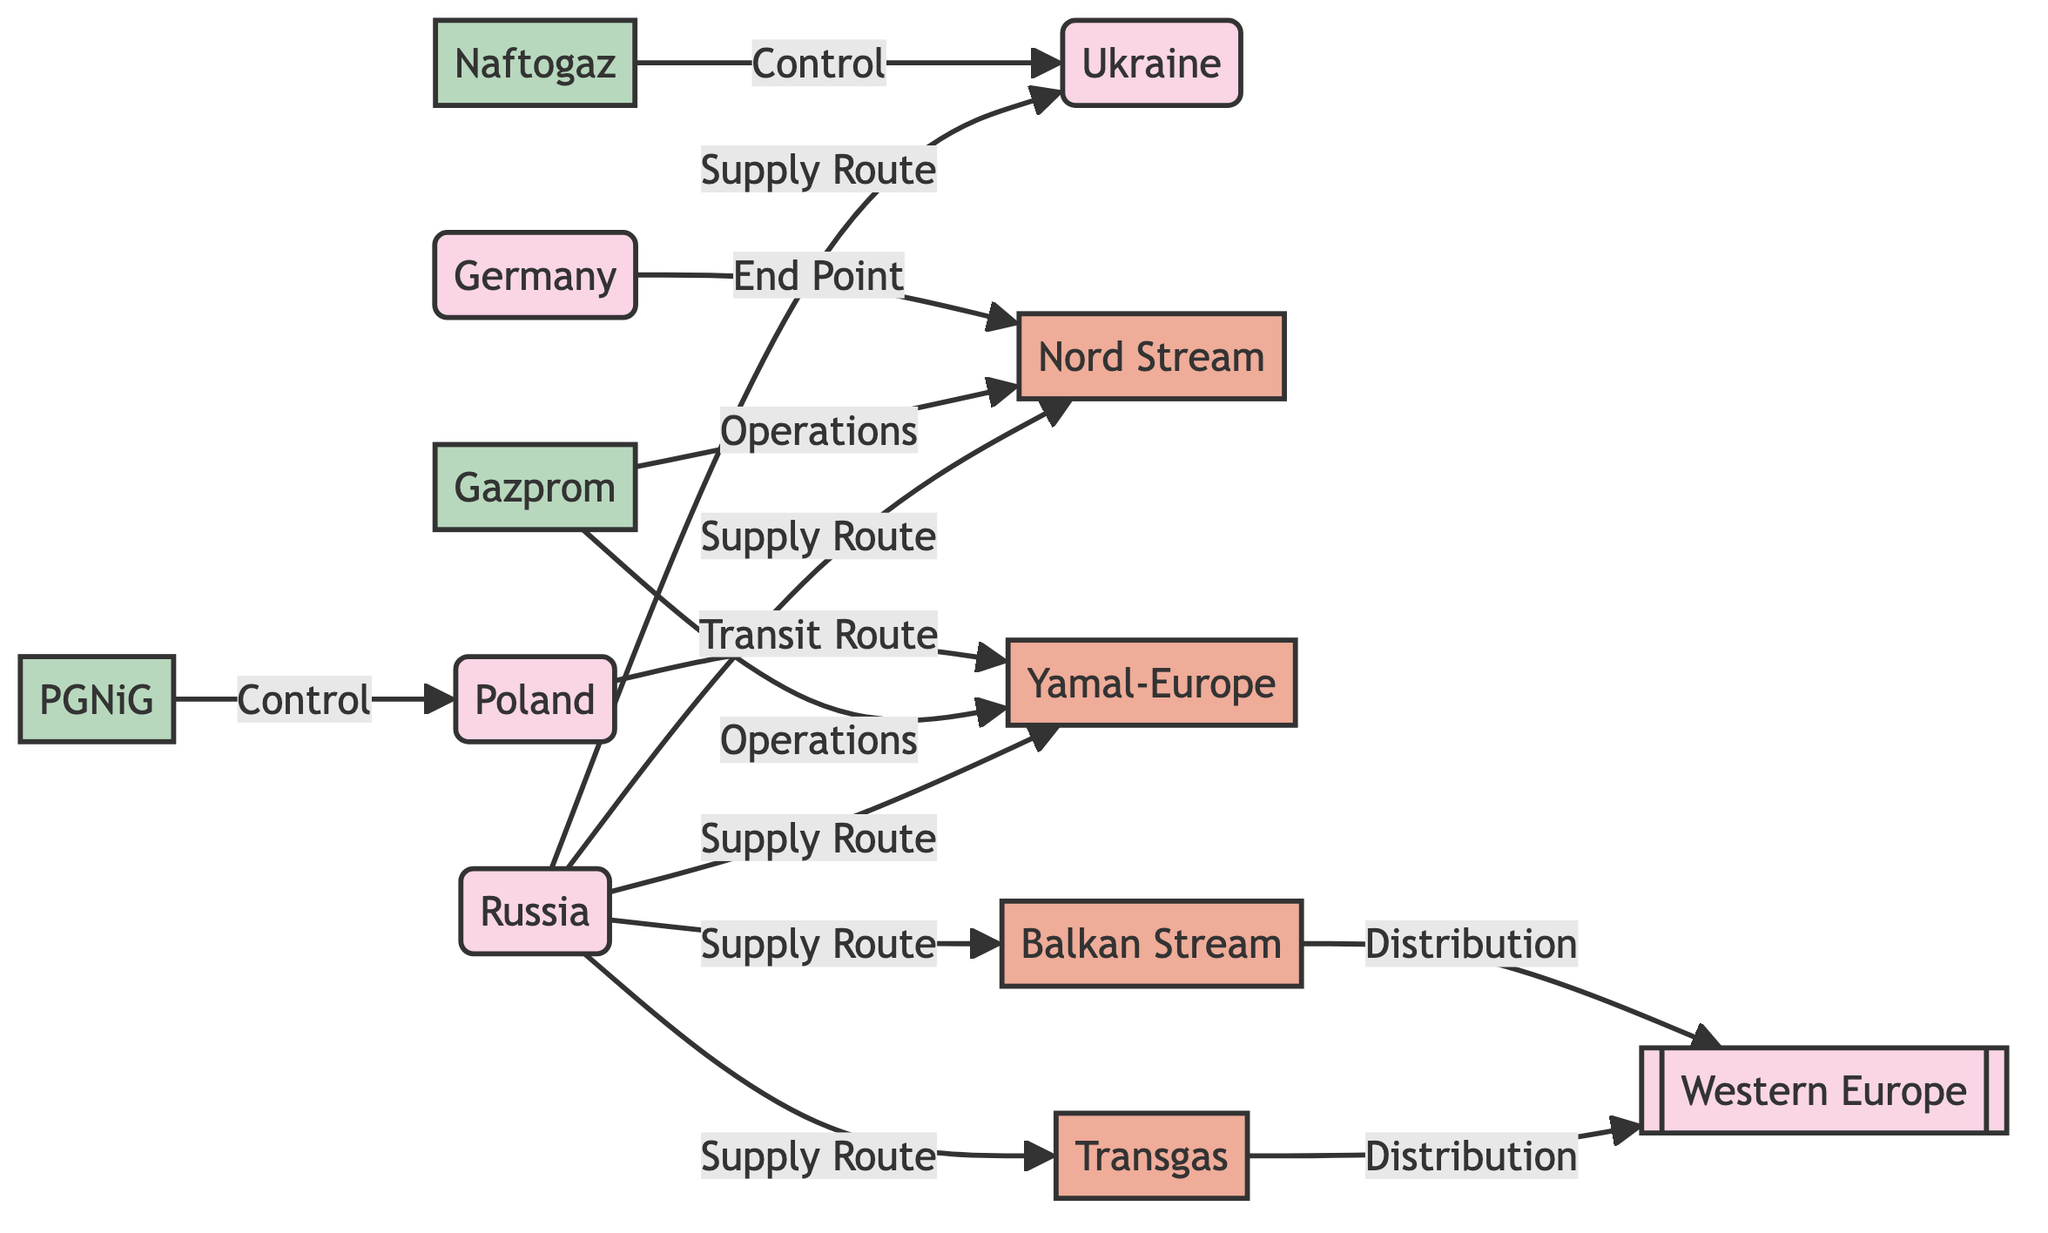What is the total number of nodes in the diagram? The diagram contains 12 nodes, which include countries, pipelines, companies, and a cluster. This is counted by simply enumerating each node type listed in the data.
Answer: 12 Which country is the starting point for the supply routes? The starting point for all supply routes listed in the diagram is Russia, which has multiple direct connections to different pipelines and countries.
Answer: Russia How many pipelines are represented in the diagram? The diagram shows 5 distinct pipelines, namely Nord Stream, Yamal-Europe, Transgas, Balkan Stream, and Yamal. This is determined by counting each unique pipeline node identified in the data.
Answer: 5 Which company oversees the Nord Stream pipeline? The company Gazprom is responsible for operations concerning the Nord Stream pipeline, as indicated by the edge labeled "Operations" connecting Gazprom and Nord Stream.
Answer: Gazprom What is the endpoint for the Nord Stream pipeline? The endpoint of the Nord Stream pipeline is Germany, which is directly linked through the "End Point" labeled edge from Germany to Nord Stream.
Answer: Germany Which pipeline does Poland transit for gas supply? Poland serves as a transit route for the Yamal pipeline, indicated by the edge labeled "Transit Route" connecting Poland to Yamal.
Answer: Yamal How many distribution routes lead to Western Europe? There are 2 distribution routes leading to Western Europe, represented by the Transgas and Balkan Stream pipelines, both of which have edges labeled "Distribution" connecting them to the EnergyRecipients cluster.
Answer: 2 Who controls the gas supply to Ukraine? The control over the gas supply to Ukraine is held by Naftogaz, as indicated by the edge labeled "Control" connecting Naftogaz to Ukraine.
Answer: Naftogaz What type of relationship connects Gazprom to the Yamal pipeline? Gazprom has an "Operations" relationship with the Yamal pipeline, as indicated by the edge connecting them with that label in the diagram.
Answer: Operations 